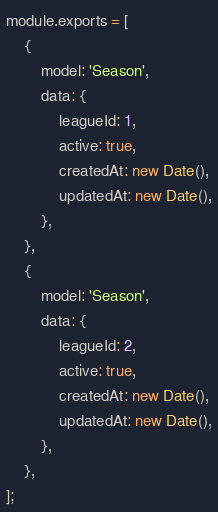Convert code to text. <code><loc_0><loc_0><loc_500><loc_500><_JavaScript_>module.exports = [
    {
        model: 'Season',
        data: {
            leagueId: 1,
            active: true,
            createdAt: new Date(),
            updatedAt: new Date(),
        },
    },
    {
        model: 'Season',
        data: {
            leagueId: 2,
            active: true,
            createdAt: new Date(),
            updatedAt: new Date(),
        },
    },
];
</code> 